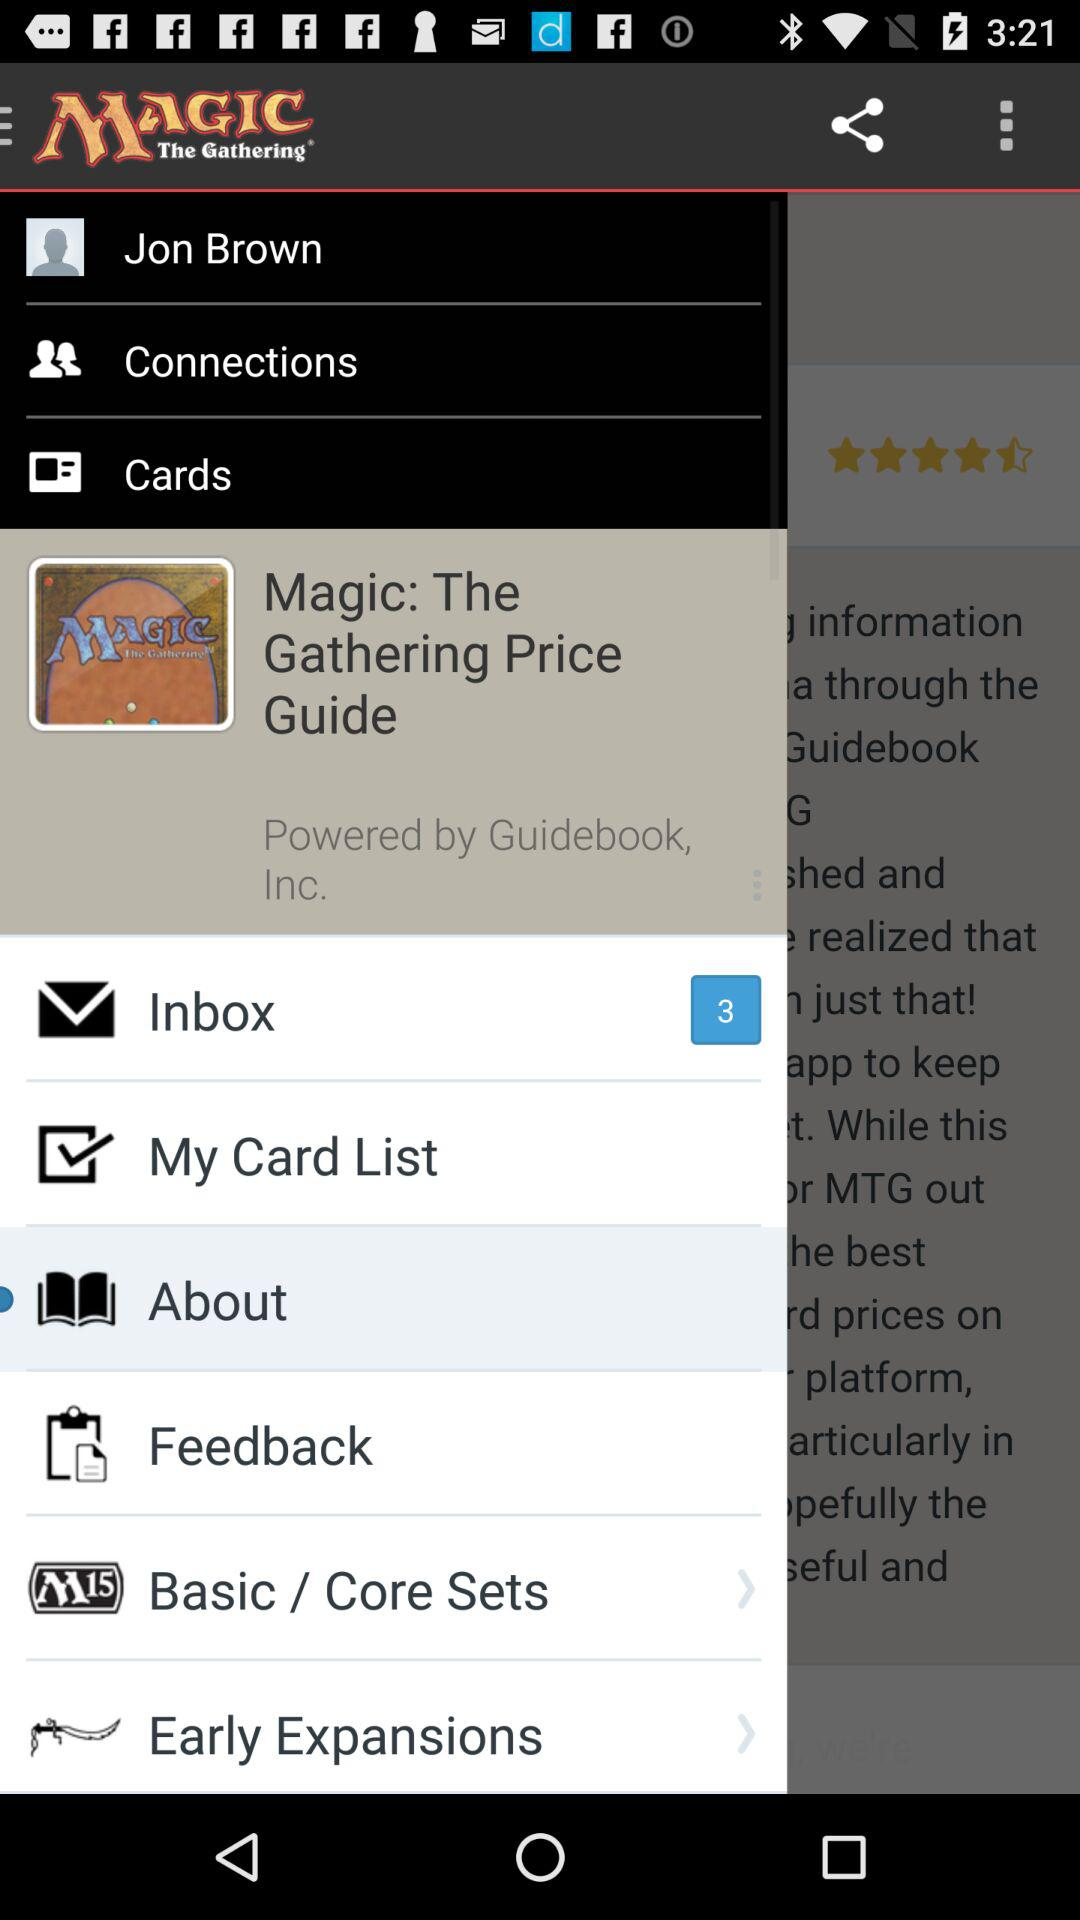What is the number of new messages in the inbox? The number of new messages in the inbox is 3. 